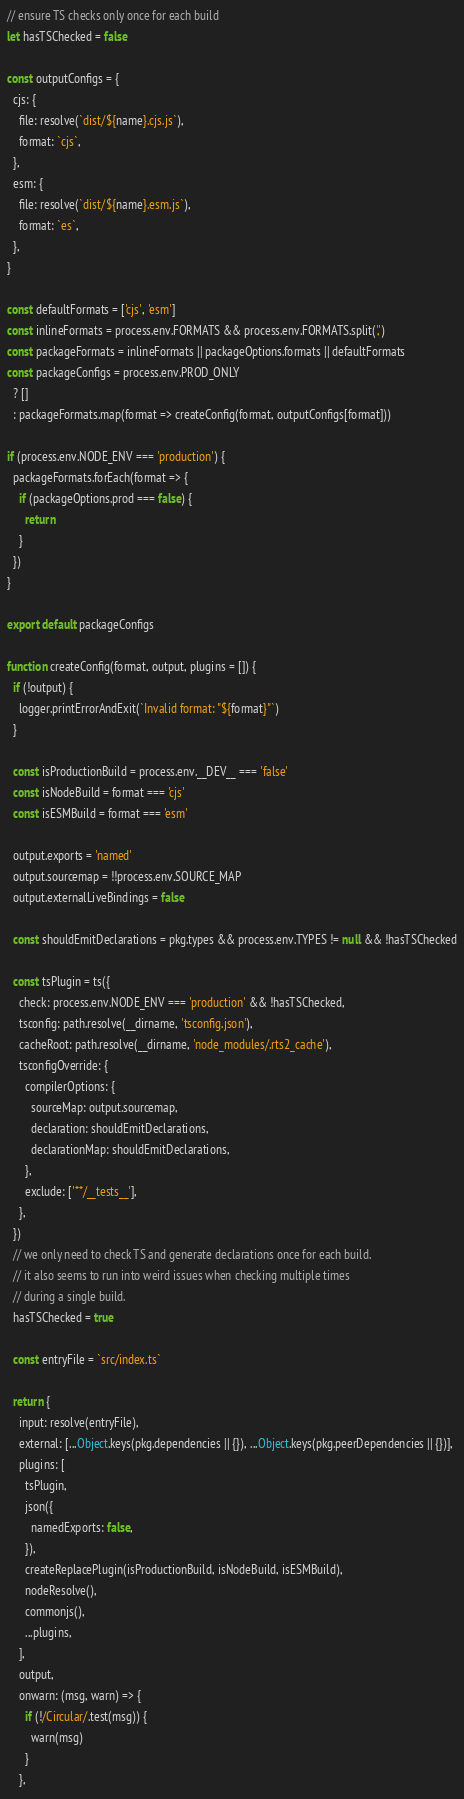<code> <loc_0><loc_0><loc_500><loc_500><_JavaScript_>
// ensure TS checks only once for each build
let hasTSChecked = false

const outputConfigs = {
  cjs: {
    file: resolve(`dist/${name}.cjs.js`),
    format: `cjs`,
  },
  esm: {
    file: resolve(`dist/${name}.esm.js`),
    format: `es`,
  },
}

const defaultFormats = ['cjs', 'esm']
const inlineFormats = process.env.FORMATS && process.env.FORMATS.split(',')
const packageFormats = inlineFormats || packageOptions.formats || defaultFormats
const packageConfigs = process.env.PROD_ONLY
  ? []
  : packageFormats.map(format => createConfig(format, outputConfigs[format]))

if (process.env.NODE_ENV === 'production') {
  packageFormats.forEach(format => {
    if (packageOptions.prod === false) {
      return
    }
  })
}

export default packageConfigs

function createConfig(format, output, plugins = []) {
  if (!output) {
    logger.printErrorAndExit(`Invalid format: "${format}"`)
  }

  const isProductionBuild = process.env.__DEV__ === 'false'
  const isNodeBuild = format === 'cjs'
  const isESMBuild = format === 'esm'

  output.exports = 'named'
  output.sourcemap = !!process.env.SOURCE_MAP
  output.externalLiveBindings = false

  const shouldEmitDeclarations = pkg.types && process.env.TYPES != null && !hasTSChecked

  const tsPlugin = ts({
    check: process.env.NODE_ENV === 'production' && !hasTSChecked,
    tsconfig: path.resolve(__dirname, 'tsconfig.json'),
    cacheRoot: path.resolve(__dirname, 'node_modules/.rts2_cache'),
    tsconfigOverride: {
      compilerOptions: {
        sourceMap: output.sourcemap,
        declaration: shouldEmitDeclarations,
        declarationMap: shouldEmitDeclarations,
      },
      exclude: ['**/__tests__'],
    },
  })
  // we only need to check TS and generate declarations once for each build.
  // it also seems to run into weird issues when checking multiple times
  // during a single build.
  hasTSChecked = true

  const entryFile = `src/index.ts`

  return {
    input: resolve(entryFile),
    external: [...Object.keys(pkg.dependencies || {}), ...Object.keys(pkg.peerDependencies || {})],
    plugins: [
      tsPlugin,
      json({
        namedExports: false,
      }),
      createReplacePlugin(isProductionBuild, isNodeBuild, isESMBuild),
      nodeResolve(),
      commonjs(),
      ...plugins,
    ],
    output,
    onwarn: (msg, warn) => {
      if (!/Circular/.test(msg)) {
        warn(msg)
      }
    },</code> 